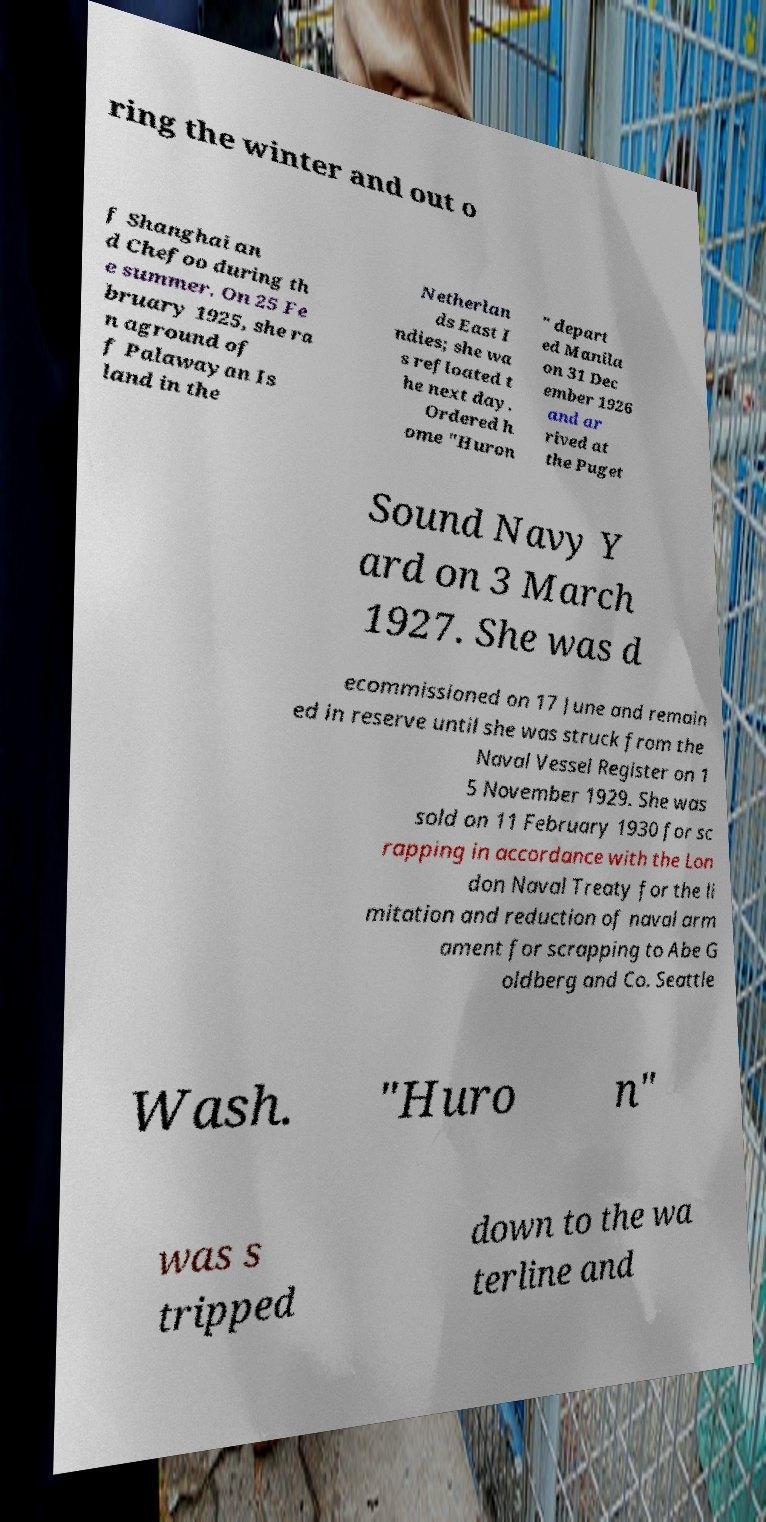Can you read and provide the text displayed in the image?This photo seems to have some interesting text. Can you extract and type it out for me? ring the winter and out o f Shanghai an d Chefoo during th e summer. On 25 Fe bruary 1925, she ra n aground of f Palawayan Is land in the Netherlan ds East I ndies; she wa s refloated t he next day. Ordered h ome "Huron " depart ed Manila on 31 Dec ember 1926 and ar rived at the Puget Sound Navy Y ard on 3 March 1927. She was d ecommissioned on 17 June and remain ed in reserve until she was struck from the Naval Vessel Register on 1 5 November 1929. She was sold on 11 February 1930 for sc rapping in accordance with the Lon don Naval Treaty for the li mitation and reduction of naval arm ament for scrapping to Abe G oldberg and Co. Seattle Wash. "Huro n" was s tripped down to the wa terline and 